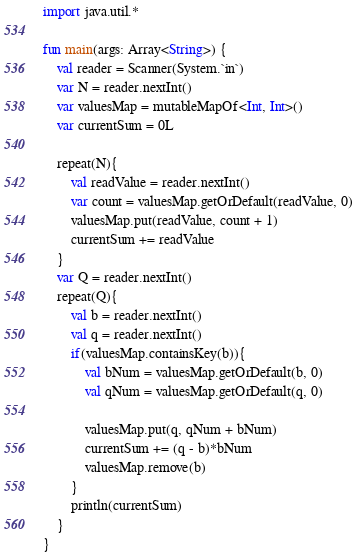<code> <loc_0><loc_0><loc_500><loc_500><_Kotlin_>import java.util.*

fun main(args: Array<String>) {
    val reader = Scanner(System.`in`)
    var N = reader.nextInt()
    var valuesMap = mutableMapOf<Int, Int>()
    var currentSum = 0L

    repeat(N){
        val readValue = reader.nextInt()
        var count = valuesMap.getOrDefault(readValue, 0)
        valuesMap.put(readValue, count + 1)
        currentSum += readValue
    }
    var Q = reader.nextInt()
    repeat(Q){
        val b = reader.nextInt()
        val q = reader.nextInt()
        if(valuesMap.containsKey(b)){
            val bNum = valuesMap.getOrDefault(b, 0)
            val qNum = valuesMap.getOrDefault(q, 0)
            
            valuesMap.put(q, qNum + bNum)
            currentSum += (q - b)*bNum
            valuesMap.remove(b)
        }
        println(currentSum)
    }
}</code> 